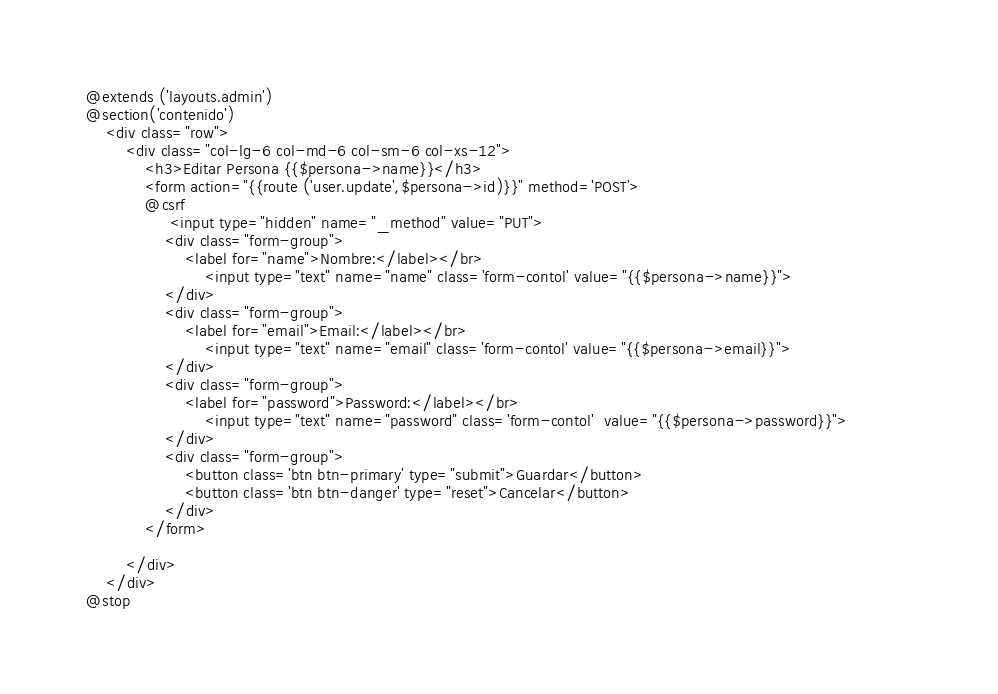Convert code to text. <code><loc_0><loc_0><loc_500><loc_500><_PHP_>@extends ('layouts.admin')
@section('contenido')
    <div class="row">
        <div class="col-lg-6 col-md-6 col-sm-6 col-xs-12">
            <h3>Editar Persona {{$persona->name}}</h3>
            <form action="{{route ('user.update',$persona->id)}}" method='POST'>          
            @csrf
                 <input type="hidden" name="_method" value="PUT">
                <div class="form-group">
                    <label for="name">Nombre:</label></br>
                        <input type="text" name="name" class='form-contol' value="{{$persona->name}}">  
                </div>
                <div class="form-group">
                    <label for="email">Email:</label></br>
                        <input type="text" name="email" class='form-contol' value="{{$persona->email}}">
                </div>
                <div class="form-group">
                    <label for="password">Password:</label></br>
                        <input type="text" name="password" class='form-contol'  value="{{$persona->password}}">             
                </div>
                <div class="form-group">
                    <button class='btn btn-primary' type="submit">Guardar</button>
                    <button class='btn btn-danger' type="reset">Cancelar</button>
                </div>
            </form>
            
        </div>
    </div>
@stop
</code> 